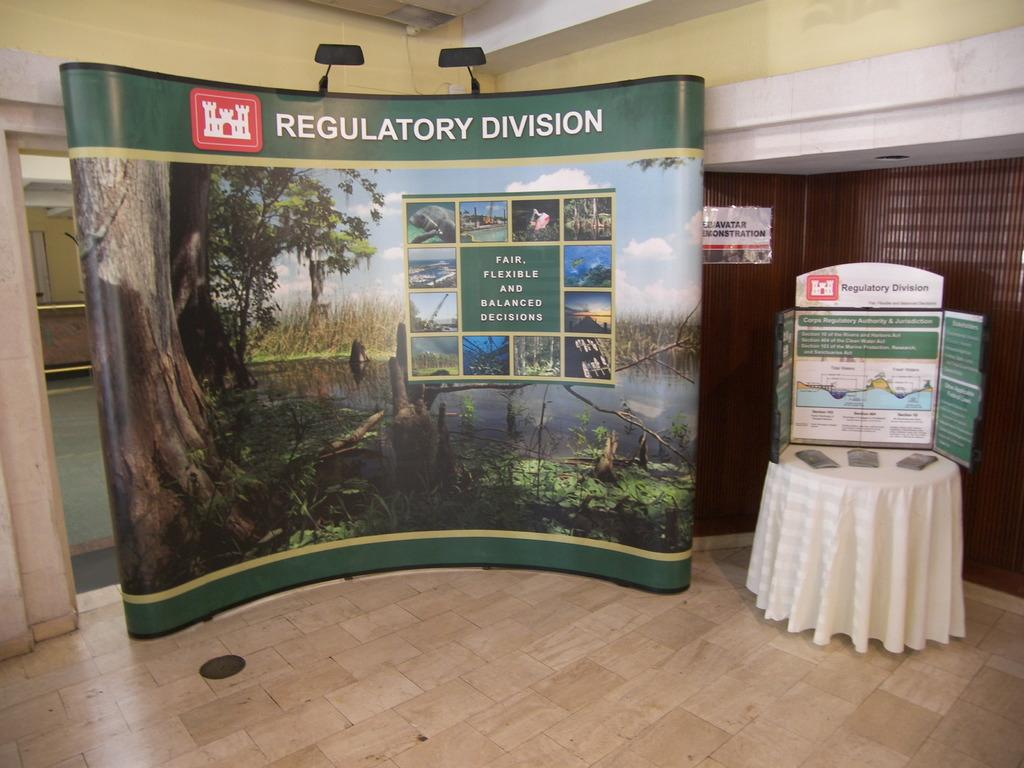What is the main object in the middle of the image? There is a banner in the middle of the image. What can be seen on the right side of the image? There are papers on a table on the right side of the image. What is visible in the background of the image? There are walls visible in the background of the image. How many yaks are present in the image? There are no yaks present in the image. What type of pies can be seen on the table in the image? There are no pies present in the image; only papers are visible on the table. 